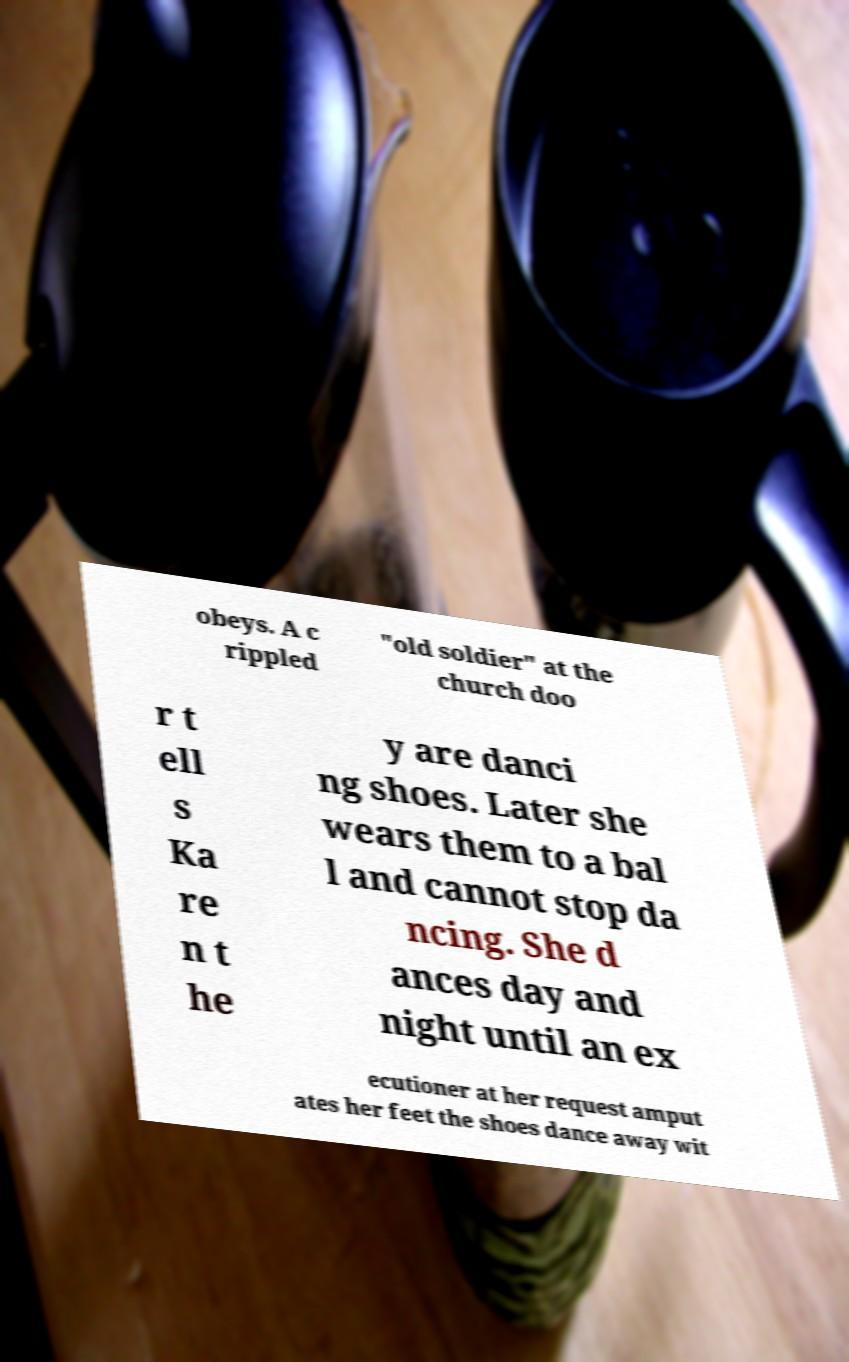What messages or text are displayed in this image? I need them in a readable, typed format. obeys. A c rippled "old soldier" at the church doo r t ell s Ka re n t he y are danci ng shoes. Later she wears them to a bal l and cannot stop da ncing. She d ances day and night until an ex ecutioner at her request amput ates her feet the shoes dance away wit 